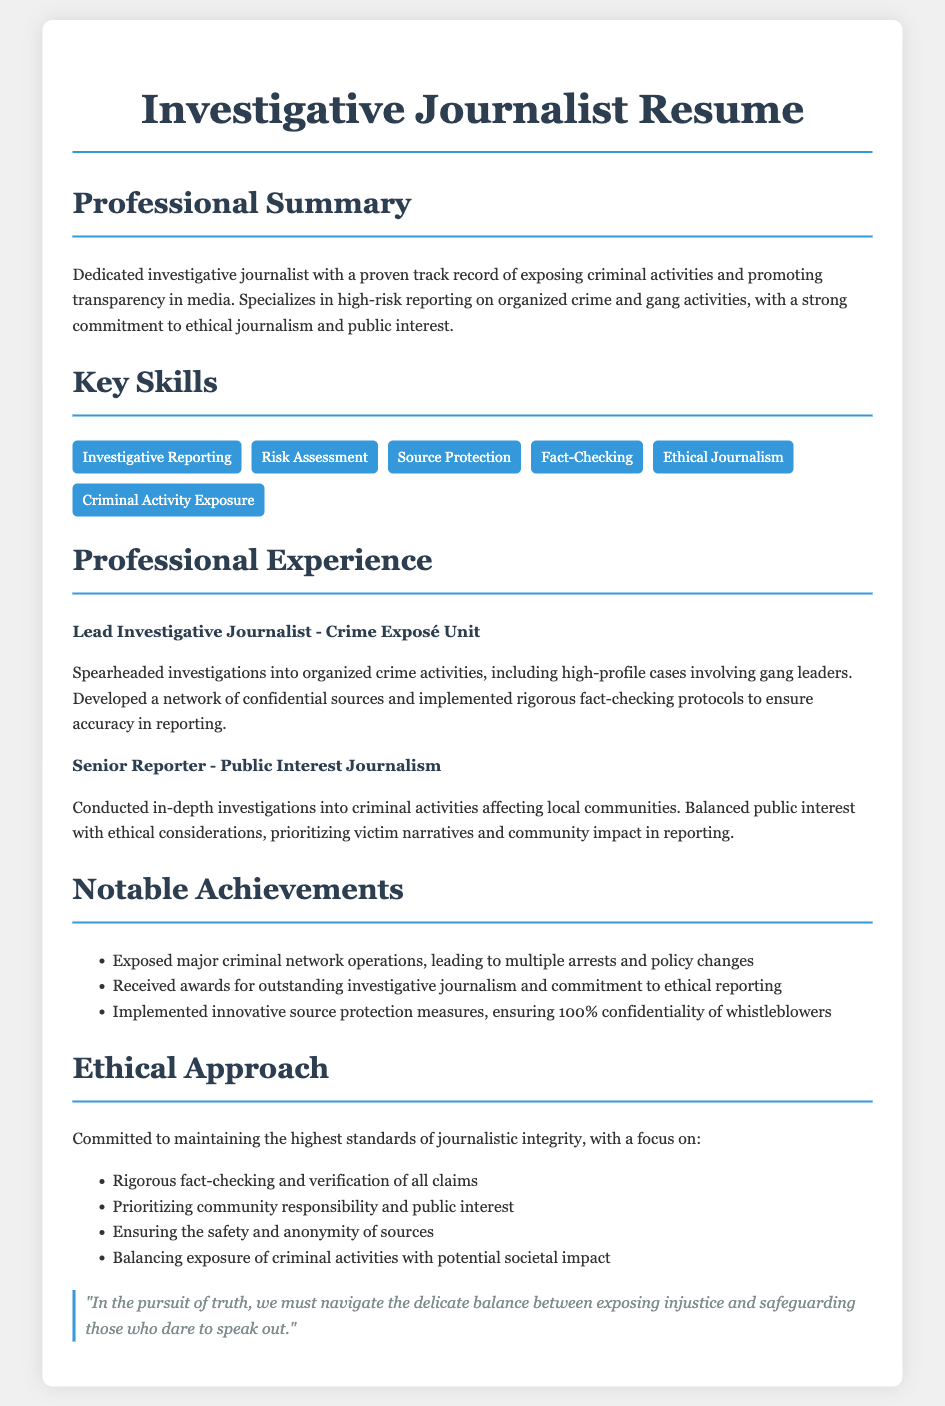what is the title of the resume? The title of the resume is prominently displayed at the top as "Investigative Journalist Resume."
Answer: Investigative Journalist Resume who is the lead investigative journalist? The lead investigative journalist's position is stated as "Lead Investigative Journalist - Crime Exposé Unit."
Answer: Lead Investigative Journalist - Crime Exposé Unit how many notable achievements are listed? The document lists three notable achievements under the Notable Achievements section.
Answer: 3 what is one key skill mentioned in the resume? Key skills are listed under the Key Skills section, including "Investigative Reporting."
Answer: Investigative Reporting what is the main focus of the ethical approach? The ethical approach emphasizes maintaining "the highest standards of journalistic integrity."
Answer: highest standards of journalistic integrity what type of journalism does the senior reporter specialize in? The senior reporter is noted to work in "Public Interest Journalism."
Answer: Public Interest Journalism what kind of protection measures were implemented? The document mentions "innovative source protection measures" were implemented.
Answer: innovative source protection measures what qualification is prioritized in the professional experience section? The professional experience section highlights the importance of "ethical considerations" in reporting.
Answer: ethical considerations how is community impact addressed in reporting according to the resume? The resume states that the journalist "prioritizes victim narratives and community impact in reporting."
Answer: prioritizes victim narratives and community impact in reporting 